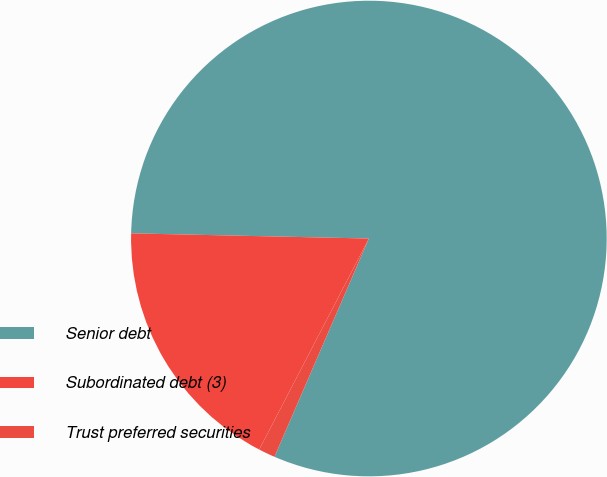Convert chart. <chart><loc_0><loc_0><loc_500><loc_500><pie_chart><fcel>Senior debt<fcel>Subordinated debt (3)<fcel>Trust preferred securities<nl><fcel>81.16%<fcel>17.72%<fcel>1.13%<nl></chart> 